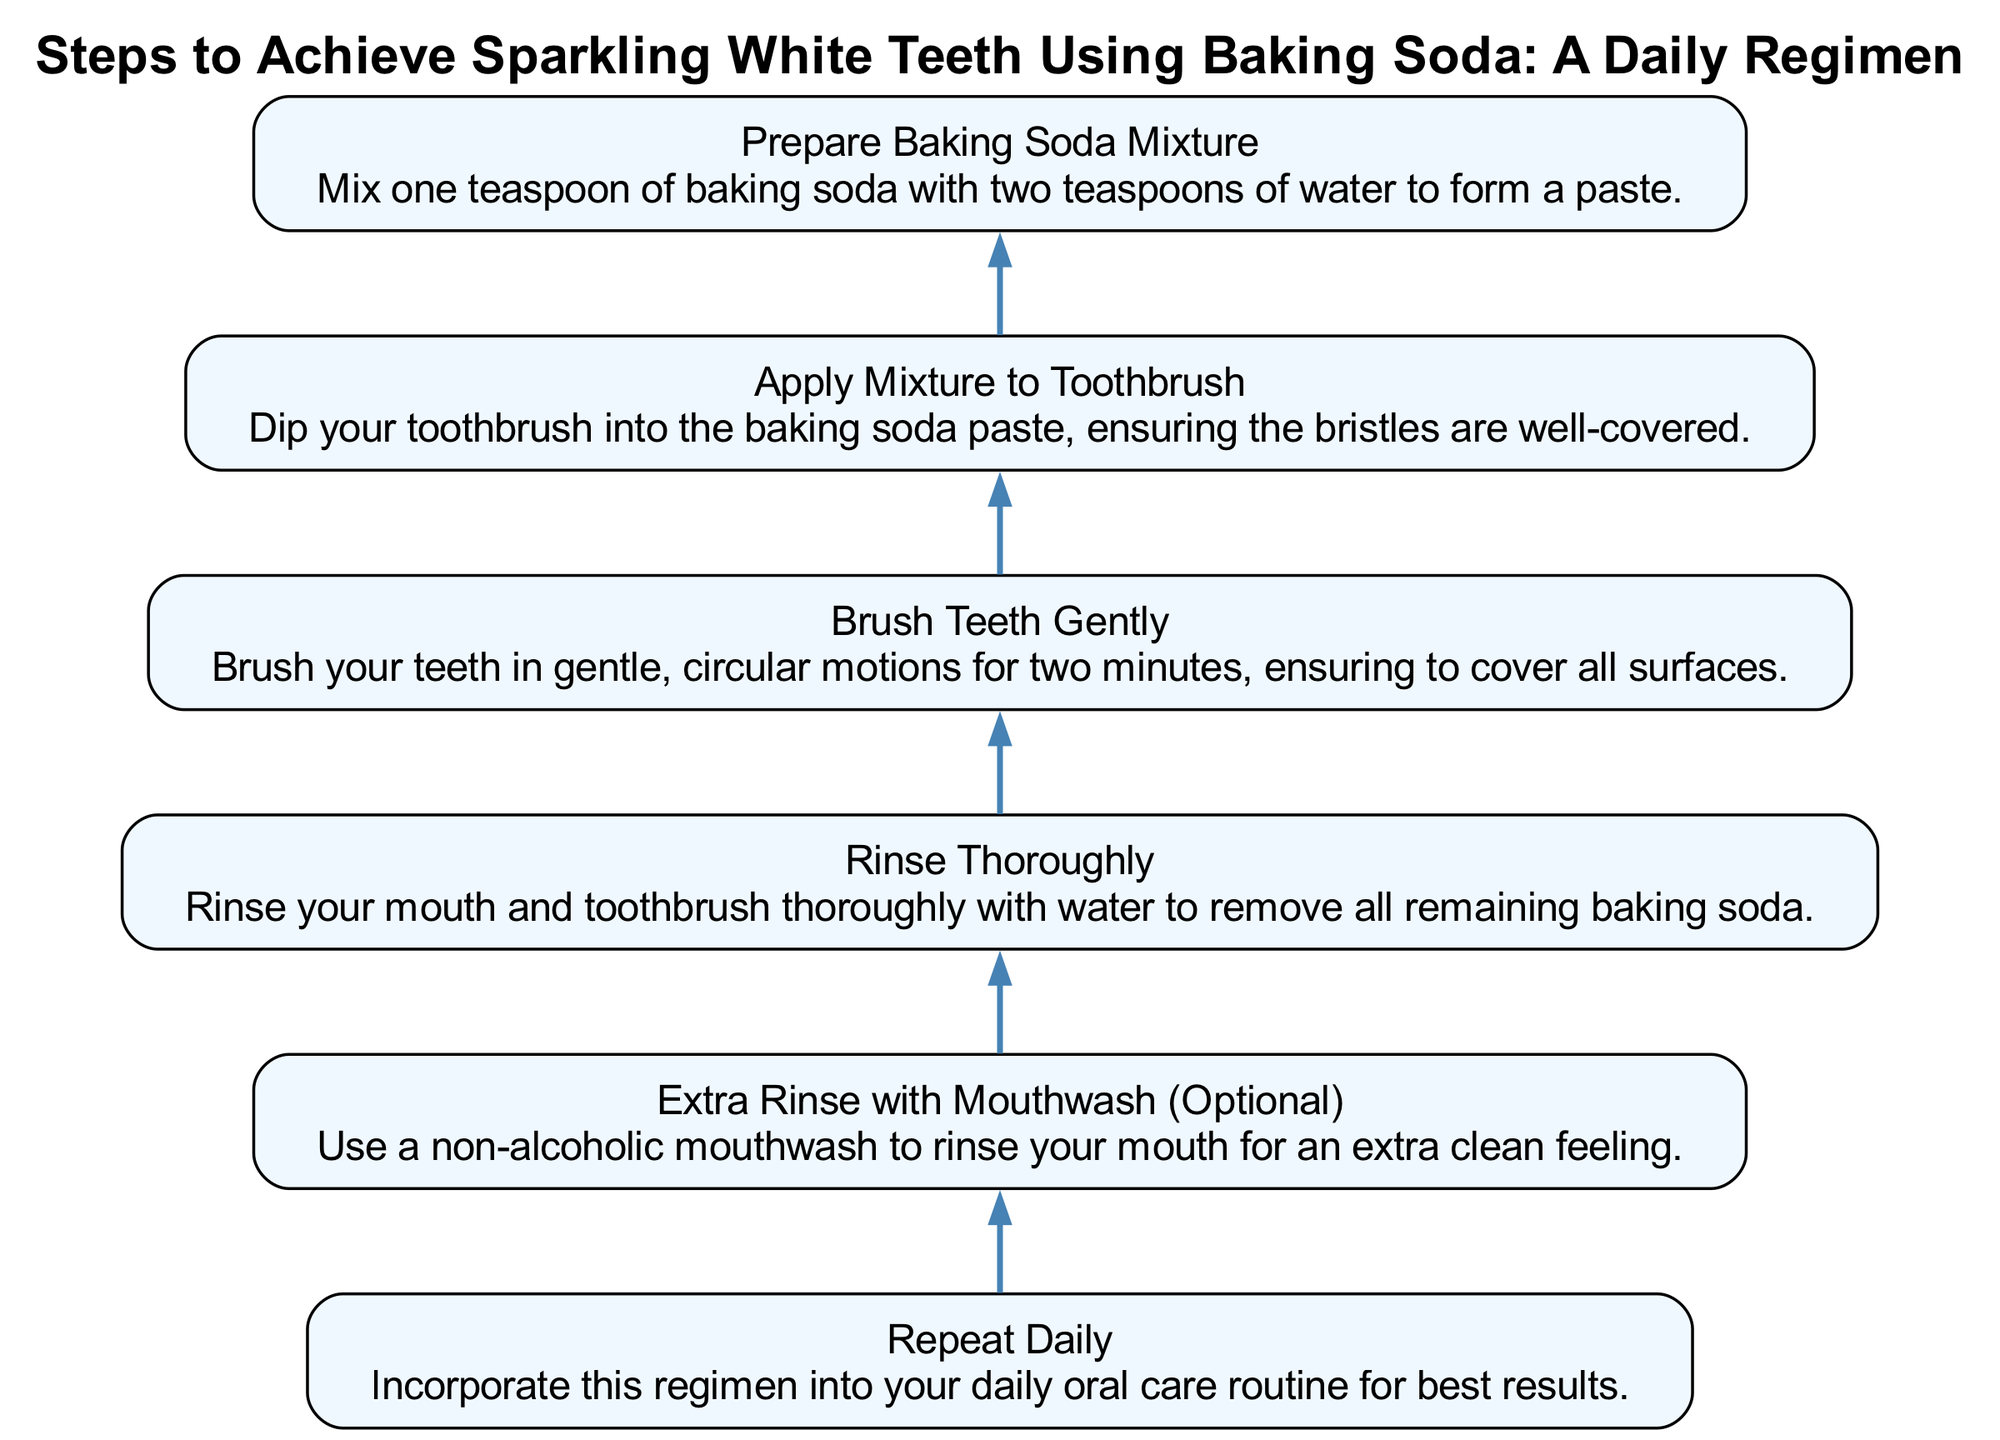What is the first step in the diagram? The first step, which is at the bottom of the flow chart, is "Prepare Baking Soda Mixture," where it instructs to mix one teaspoon of baking soda with two teaspoons of water to form a paste.
Answer: Prepare Baking Soda Mixture How many steps are included in the diagram? Counting all the steps listed in the flow chart, there are a total of six steps, starting from preparing the mixture to repeating the daily regimen.
Answer: Six What step comes after "Brush Teeth Gently"? Following the step "Brush Teeth Gently," the next step is "Rinse Thoroughly," where you need to rinse your mouth and toothbrush thoroughly with water.
Answer: Rinse Thoroughly Which step includes an optional action? The step titled "Extra Rinse with Mouthwash (Optional)" indicates that this is an additional step you can take for an extra clean feeling, making it optional.
Answer: Extra Rinse with Mouthwash (Optional) If someone completes all the steps, what should they do next? After completing the last step of the flow chart, which is "Repeat Daily," it is suggested to integrate this regimen into your daily oral care routine for the best results.
Answer: Repeat Daily What does the "Apply Mixture to Toothbrush" step instruct? In the step "Apply Mixture to Toothbrush," it instructs to dip your toothbrush into the baking soda paste and ensure the bristles are well-covered before brushing.
Answer: Dip your toothbrush into the baking soda paste What is the relationship between "Rinse Thoroughly" and "Extra Rinse with Mouthwash"? "Rinse Thoroughly" is the step that comes directly before "Extra Rinse with Mouthwash," indicating that it should be completed first, with the mouthwash rinse being an optional follow-up for extra cleanliness.
Answer: Sequential steps Which step requires gentle motion? The step that requires gentle motion is "Brush Teeth Gently," where you are instructed to brush in gentle, circular motions to effectively clean your teeth.
Answer: Brush Teeth Gently 